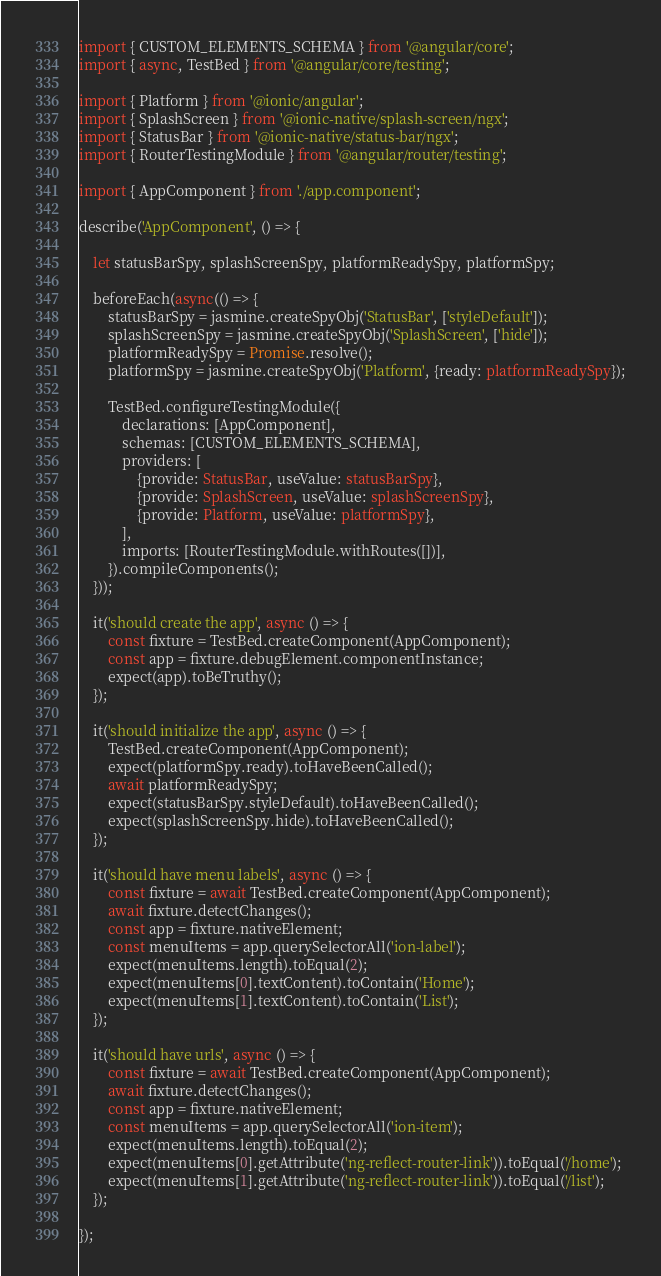Convert code to text. <code><loc_0><loc_0><loc_500><loc_500><_TypeScript_>import { CUSTOM_ELEMENTS_SCHEMA } from '@angular/core';
import { async, TestBed } from '@angular/core/testing';

import { Platform } from '@ionic/angular';
import { SplashScreen } from '@ionic-native/splash-screen/ngx';
import { StatusBar } from '@ionic-native/status-bar/ngx';
import { RouterTestingModule } from '@angular/router/testing';

import { AppComponent } from './app.component';

describe('AppComponent', () => {

    let statusBarSpy, splashScreenSpy, platformReadySpy, platformSpy;

    beforeEach(async(() => {
        statusBarSpy = jasmine.createSpyObj('StatusBar', ['styleDefault']);
        splashScreenSpy = jasmine.createSpyObj('SplashScreen', ['hide']);
        platformReadySpy = Promise.resolve();
        platformSpy = jasmine.createSpyObj('Platform', {ready: platformReadySpy});

        TestBed.configureTestingModule({
            declarations: [AppComponent],
            schemas: [CUSTOM_ELEMENTS_SCHEMA],
            providers: [
                {provide: StatusBar, useValue: statusBarSpy},
                {provide: SplashScreen, useValue: splashScreenSpy},
                {provide: Platform, useValue: platformSpy},
            ],
            imports: [RouterTestingModule.withRoutes([])],
        }).compileComponents();
    }));

    it('should create the app', async () => {
        const fixture = TestBed.createComponent(AppComponent);
        const app = fixture.debugElement.componentInstance;
        expect(app).toBeTruthy();
    });

    it('should initialize the app', async () => {
        TestBed.createComponent(AppComponent);
        expect(platformSpy.ready).toHaveBeenCalled();
        await platformReadySpy;
        expect(statusBarSpy.styleDefault).toHaveBeenCalled();
        expect(splashScreenSpy.hide).toHaveBeenCalled();
    });

    it('should have menu labels', async () => {
        const fixture = await TestBed.createComponent(AppComponent);
        await fixture.detectChanges();
        const app = fixture.nativeElement;
        const menuItems = app.querySelectorAll('ion-label');
        expect(menuItems.length).toEqual(2);
        expect(menuItems[0].textContent).toContain('Home');
        expect(menuItems[1].textContent).toContain('List');
    });

    it('should have urls', async () => {
        const fixture = await TestBed.createComponent(AppComponent);
        await fixture.detectChanges();
        const app = fixture.nativeElement;
        const menuItems = app.querySelectorAll('ion-item');
        expect(menuItems.length).toEqual(2);
        expect(menuItems[0].getAttribute('ng-reflect-router-link')).toEqual('/home');
        expect(menuItems[1].getAttribute('ng-reflect-router-link')).toEqual('/list');
    });

});
</code> 